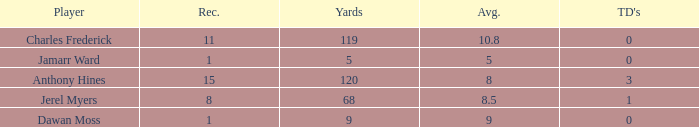What is the total Avg when TDs are 0 and Dawan Moss is a player? 0.0. 